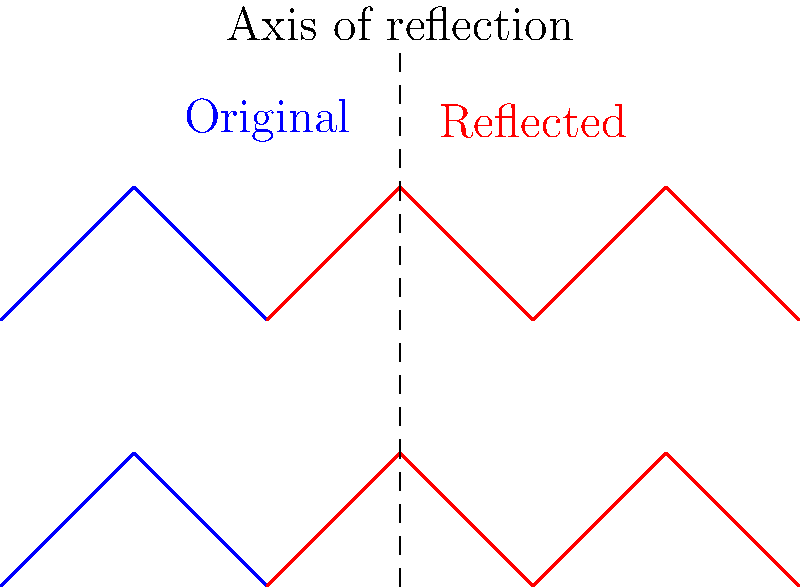As a veterinarian studying equine locomotion, you're analyzing a horse's gait diagram. The diagram shows the movement pattern of the horse's front and hind legs over time. You want to compare this pattern with its mirror image to identify any asymmetries. If the original gait diagram is reflected across the vertical axis at $x=3$, what transformation would correctly describe this reflection? To solve this problem, let's follow these steps:

1. Understand the given information:
   - We have an original gait diagram (blue) and its reflection (red).
   - The reflection is across a vertical axis at $x=3$.

2. Analyze the transformation:
   - In a reflection across a vertical line, the x-coordinates change while the y-coordinates remain the same.
   - The distance of any point from the axis of reflection remains the same on both sides.

3. Determine the transformation:
   - For any point $(x,y)$ in the original diagram, its reflection will be at $(6-x,y)$.
   - This is because:
     a) The axis of reflection is at $x=3$.
     b) The distance of any point from $x=3$ on the left side will be equal to the distance of its reflection on the right side.

4. Express the transformation mathematically:
   - The reflection can be described by the transformation $(x,y) \rightarrow (6-x,y)$.

5. Simplify the expression:
   - This can be written more concisely as $(x,y) \rightarrow (-x+6,y)$.

Therefore, the correct transformation to describe this reflection is $(x,y) \rightarrow (-x+6,y)$.
Answer: $(x,y) \rightarrow (-x+6,y)$ 